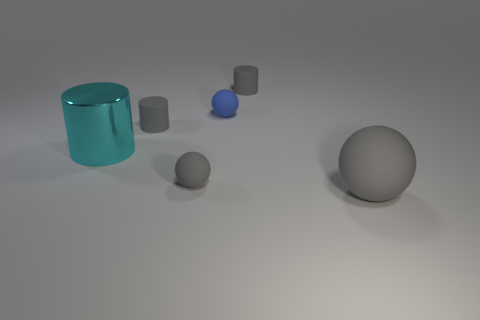Subtract all gray balls. How many balls are left? 1 Subtract 3 balls. How many balls are left? 0 Add 3 small brown matte cylinders. How many objects exist? 9 Subtract all gray balls. How many balls are left? 1 Subtract all green spheres. How many brown cylinders are left? 0 Subtract all tiny balls. Subtract all cyan things. How many objects are left? 3 Add 5 big rubber balls. How many big rubber balls are left? 6 Add 5 large gray balls. How many large gray balls exist? 6 Subtract 0 green blocks. How many objects are left? 6 Subtract all brown spheres. Subtract all yellow cubes. How many spheres are left? 3 